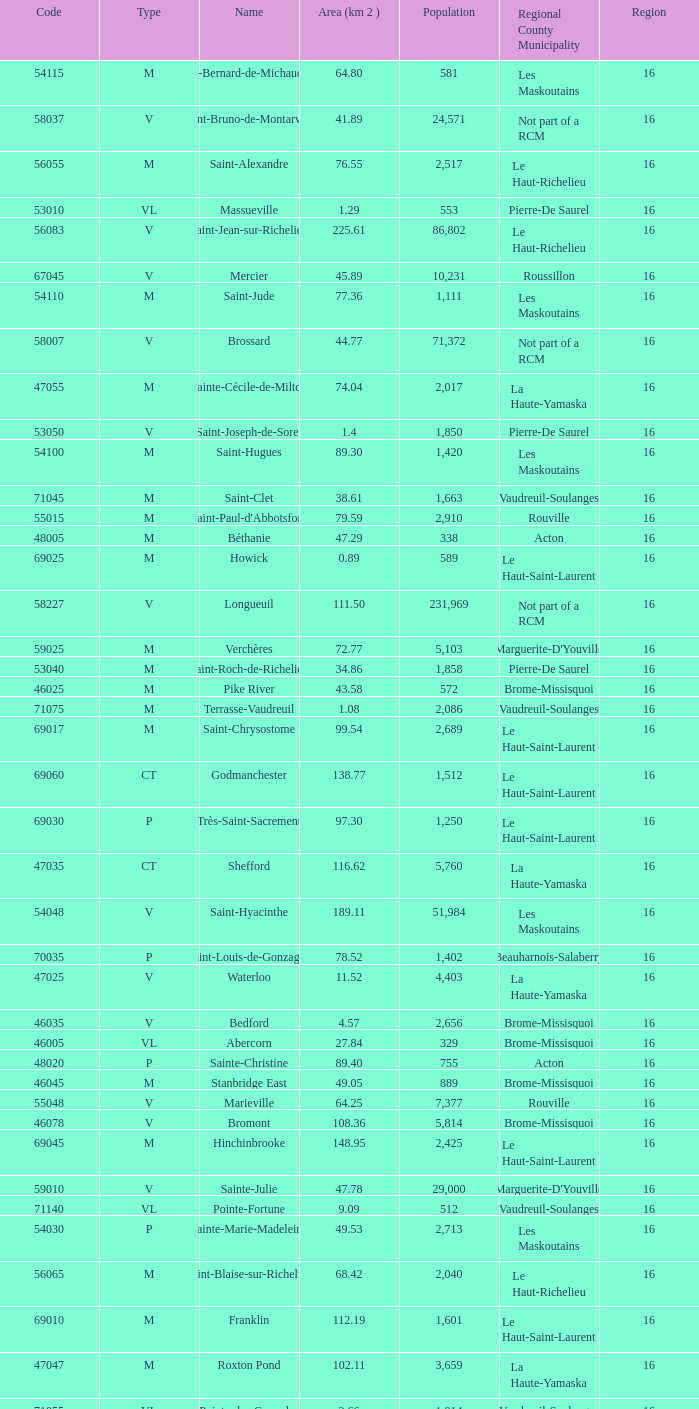Saint-Blaise-Sur-Richelieu is smaller than 68.42 km^2, what is the population of this type M municipality? None. 